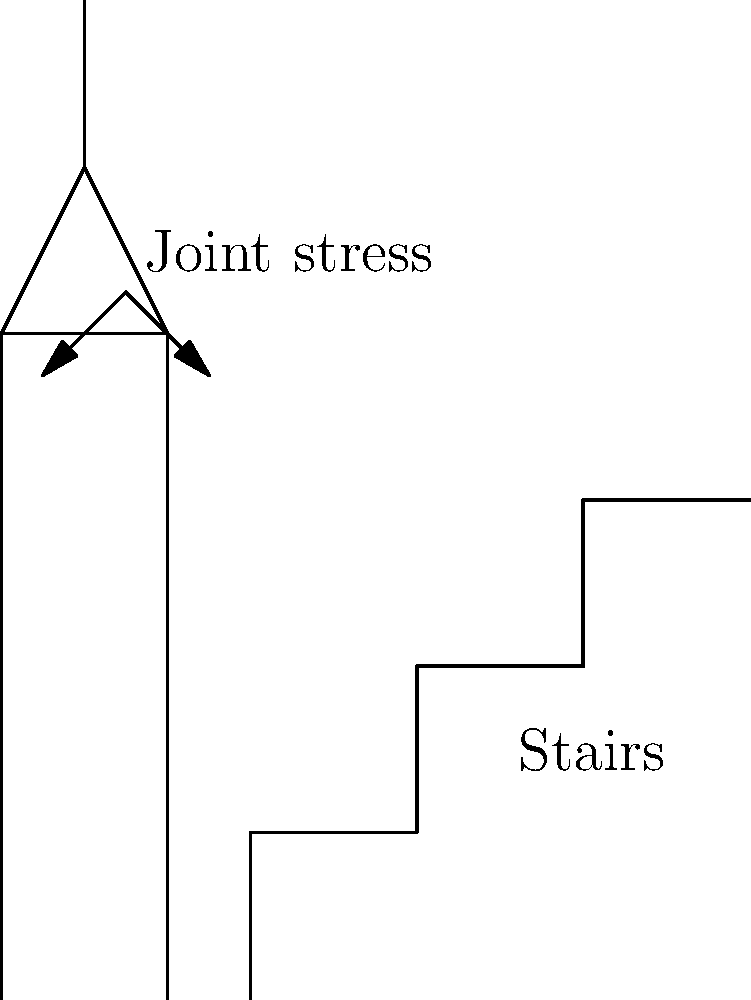In a multi-level historic building converted into a community center, visitors frequently climb stairs for various activities. How does the angle of the stairs affect the compressive force on knee joints during climbing? Consider a 70 kg person ascending stairs with a rise/run ratio of 7/11. To understand the impact of stair climbing on knee joint stress, we'll follow these steps:

1. Calculate the angle of the stairs:
   $\theta = \tan^{-1}(\frac{rise}{run}) = \tan^{-1}(\frac{7}{11}) \approx 32.5°$

2. Determine the vertical force component:
   $F_v = mg = 70 \text{ kg} \times 9.8 \text{ m/s}^2 = 686 \text{ N}$

3. Calculate the force parallel to the stairs:
   $F_{parallel} = F_v \times \sin(\theta) = 686 \text{ N} \times \sin(32.5°) \approx 369 \text{ N}$

4. Determine the force perpendicular to the stairs:
   $F_{perpendicular} = F_v \times \cos(\theta) = 686 \text{ N} \times \cos(32.5°) \approx 579 \text{ N}$

5. The compressive force on the knee joint is approximately equal to $F_{perpendicular}$.

6. Compare this to level walking, where the full 686 N would be applied to the joint.

7. The reduction in compressive force is:
   $686 \text{ N} - 579 \text{ N} = 107 \text{ N}$

8. Calculate the percentage reduction:
   $\frac{107 \text{ N}}{686 \text{ N}} \times 100\% \approx 15.6\%$

Therefore, climbing stairs with this rise/run ratio reduces the compressive force on the knee joint by about 15.6% compared to level walking.
Answer: 15.6% reduction in compressive force 